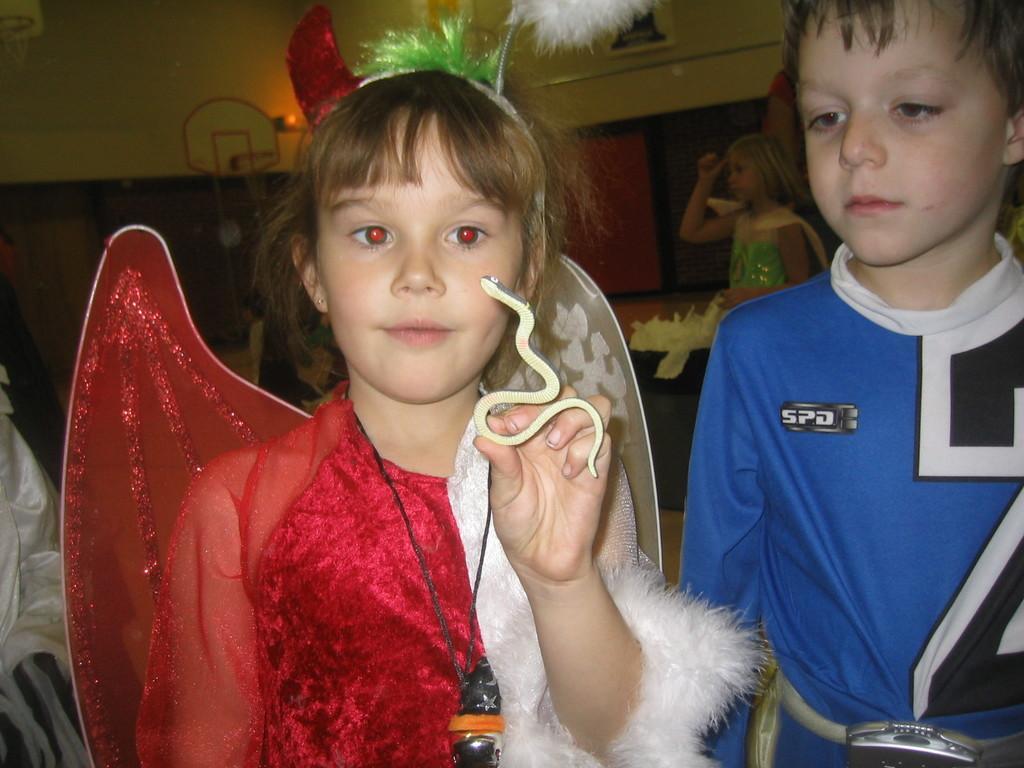Please provide a concise description of this image. On the left side, there is a girl in a red color dress, holding a toy snake with one hand. On the right side, there is a boy in blue color T-shirt, standing. In the background, there is another girl and there is a wall. 